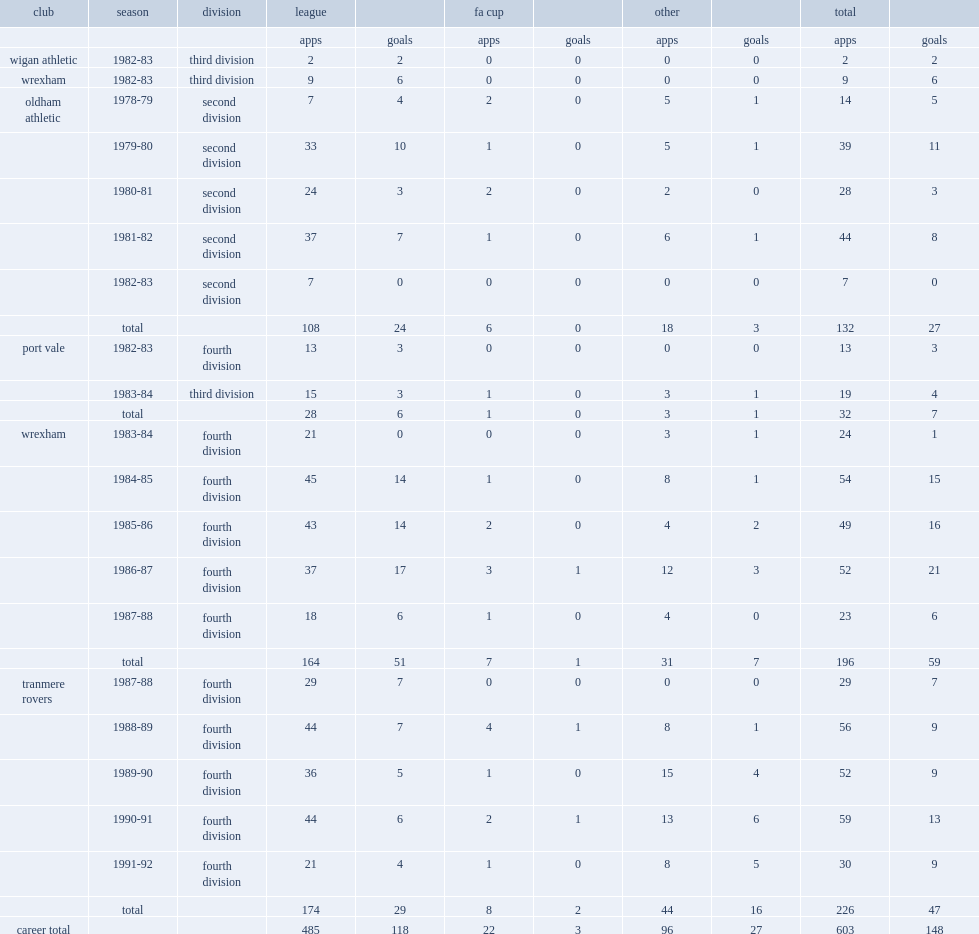Write the full table. {'header': ['club', 'season', 'division', 'league', '', 'fa cup', '', 'other', '', 'total', ''], 'rows': [['', '', '', 'apps', 'goals', 'apps', 'goals', 'apps', 'goals', 'apps', 'goals'], ['wigan athletic', '1982-83', 'third division', '2', '2', '0', '0', '0', '0', '2', '2'], ['wrexham', '1982-83', 'third division', '9', '6', '0', '0', '0', '0', '9', '6'], ['oldham athletic', '1978-79', 'second division', '7', '4', '2', '0', '5', '1', '14', '5'], ['', '1979-80', 'second division', '33', '10', '1', '0', '5', '1', '39', '11'], ['', '1980-81', 'second division', '24', '3', '2', '0', '2', '0', '28', '3'], ['', '1981-82', 'second division', '37', '7', '1', '0', '6', '1', '44', '8'], ['', '1982-83', 'second division', '7', '0', '0', '0', '0', '0', '7', '0'], ['', 'total', '', '108', '24', '6', '0', '18', '3', '132', '27'], ['port vale', '1982-83', 'fourth division', '13', '3', '0', '0', '0', '0', '13', '3'], ['', '1983-84', 'third division', '15', '3', '1', '0', '3', '1', '19', '4'], ['', 'total', '', '28', '6', '1', '0', '3', '1', '32', '7'], ['wrexham', '1983-84', 'fourth division', '21', '0', '0', '0', '3', '1', '24', '1'], ['', '1984-85', 'fourth division', '45', '14', '1', '0', '8', '1', '54', '15'], ['', '1985-86', 'fourth division', '43', '14', '2', '0', '4', '2', '49', '16'], ['', '1986-87', 'fourth division', '37', '17', '3', '1', '12', '3', '52', '21'], ['', '1987-88', 'fourth division', '18', '6', '1', '0', '4', '0', '23', '6'], ['', 'total', '', '164', '51', '7', '1', '31', '7', '196', '59'], ['tranmere rovers', '1987-88', 'fourth division', '29', '7', '0', '0', '0', '0', '29', '7'], ['', '1988-89', 'fourth division', '44', '7', '4', '1', '8', '1', '56', '9'], ['', '1989-90', 'fourth division', '36', '5', '1', '0', '15', '4', '52', '9'], ['', '1990-91', 'fourth division', '44', '6', '2', '1', '13', '6', '59', '13'], ['', '1991-92', 'fourth division', '21', '4', '1', '0', '8', '5', '30', '9'], ['', 'total', '', '174', '29', '8', '2', '44', '16', '226', '47'], ['career total', '', '', '485', '118', '22', '3', '96', '27', '603', '148']]} How many league games did jim steel play for wrexham totally. 164.0. 